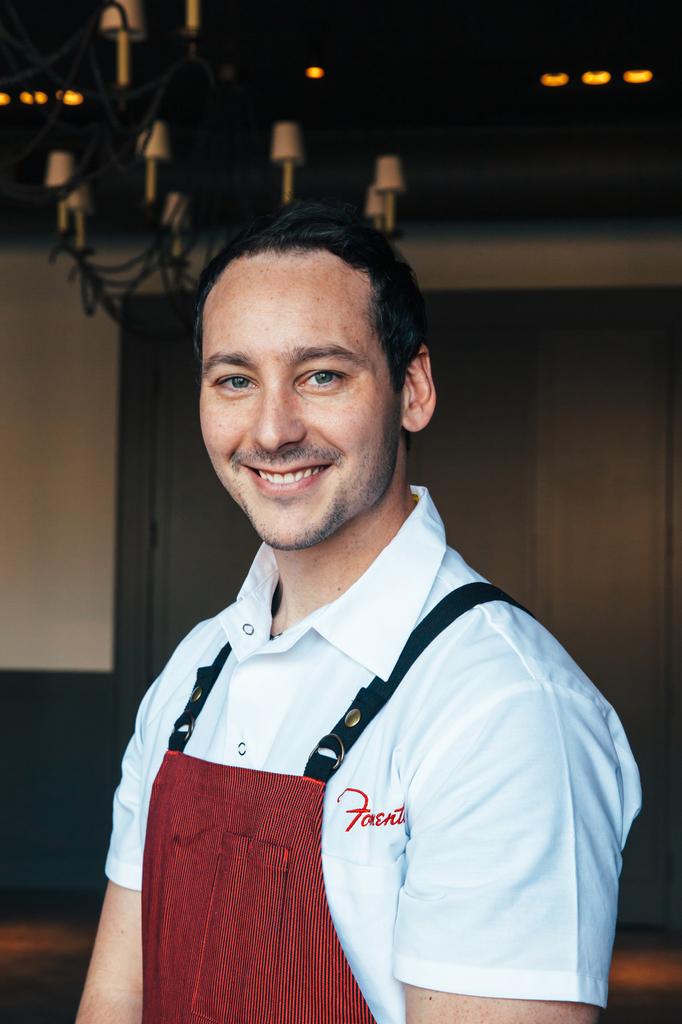Is the first letter of his shirt and "f"?
Make the answer very short. Yes. What color is the word on his shirt?
Your answer should be compact. Red. 